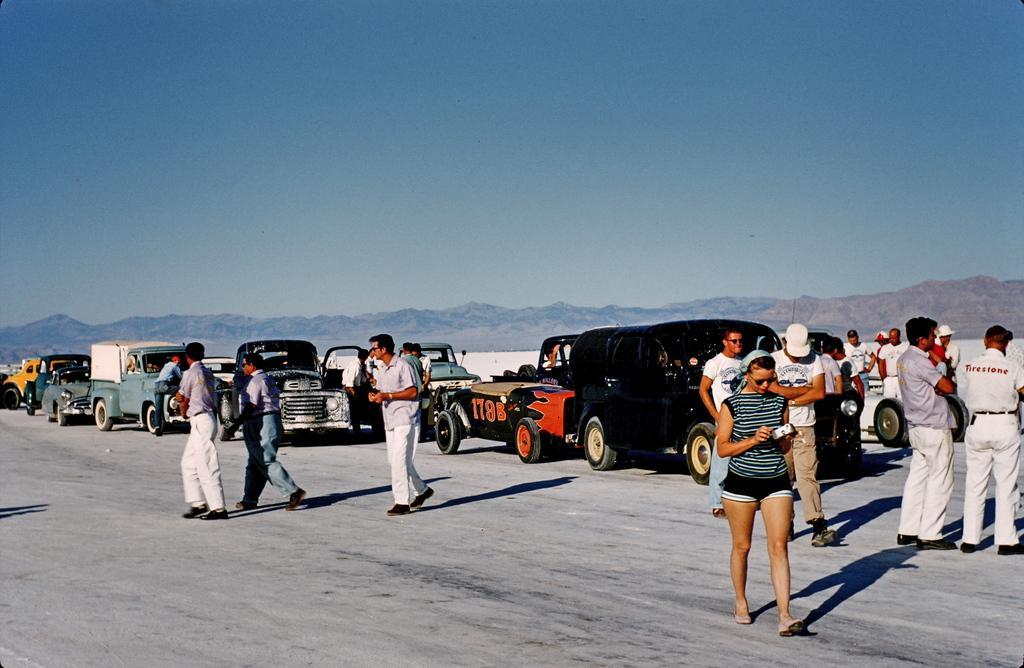Could you give a brief overview of what you see in this image? In this image we can see people standing on the road and we can also see vehicles, mountains and sky. 